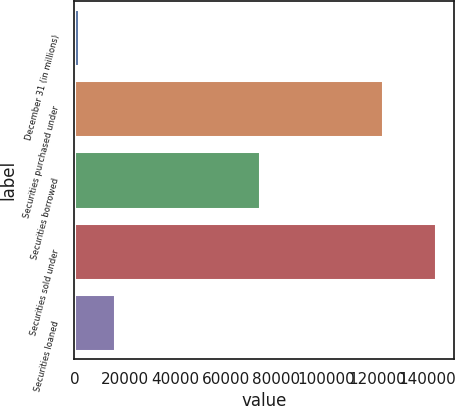Convert chart to OTSL. <chart><loc_0><loc_0><loc_500><loc_500><bar_chart><fcel>December 31 (in millions)<fcel>Securities purchased under<fcel>Securities borrowed<fcel>Securities sold under<fcel>Securities loaned<nl><fcel>2006<fcel>122479<fcel>73688<fcel>143253<fcel>16130.7<nl></chart> 